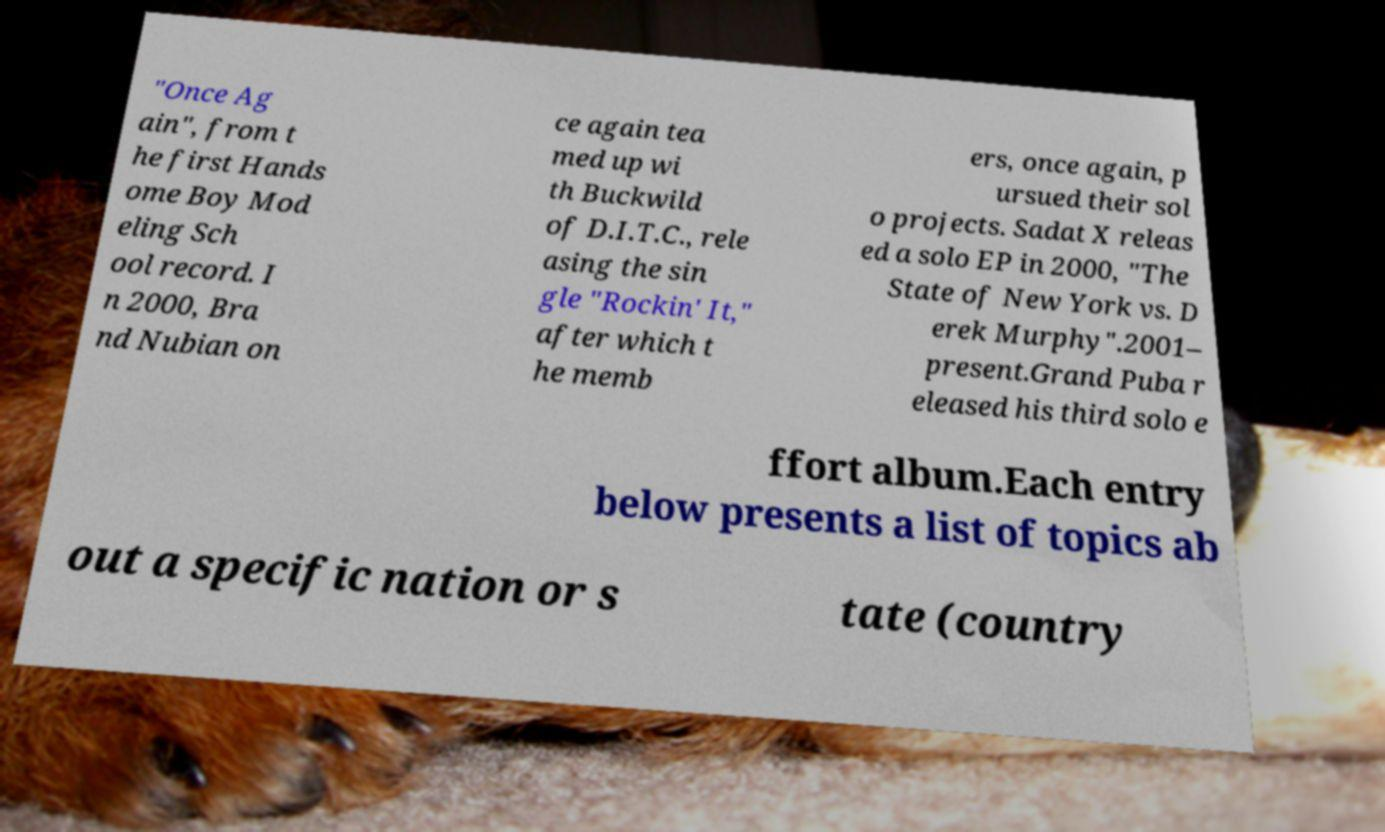What messages or text are displayed in this image? I need them in a readable, typed format. "Once Ag ain", from t he first Hands ome Boy Mod eling Sch ool record. I n 2000, Bra nd Nubian on ce again tea med up wi th Buckwild of D.I.T.C., rele asing the sin gle "Rockin' It," after which t he memb ers, once again, p ursued their sol o projects. Sadat X releas ed a solo EP in 2000, "The State of New York vs. D erek Murphy".2001– present.Grand Puba r eleased his third solo e ffort album.Each entry below presents a list of topics ab out a specific nation or s tate (country 